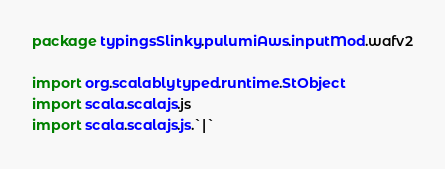<code> <loc_0><loc_0><loc_500><loc_500><_Scala_>package typingsSlinky.pulumiAws.inputMod.wafv2

import org.scalablytyped.runtime.StObject
import scala.scalajs.js
import scala.scalajs.js.`|`</code> 